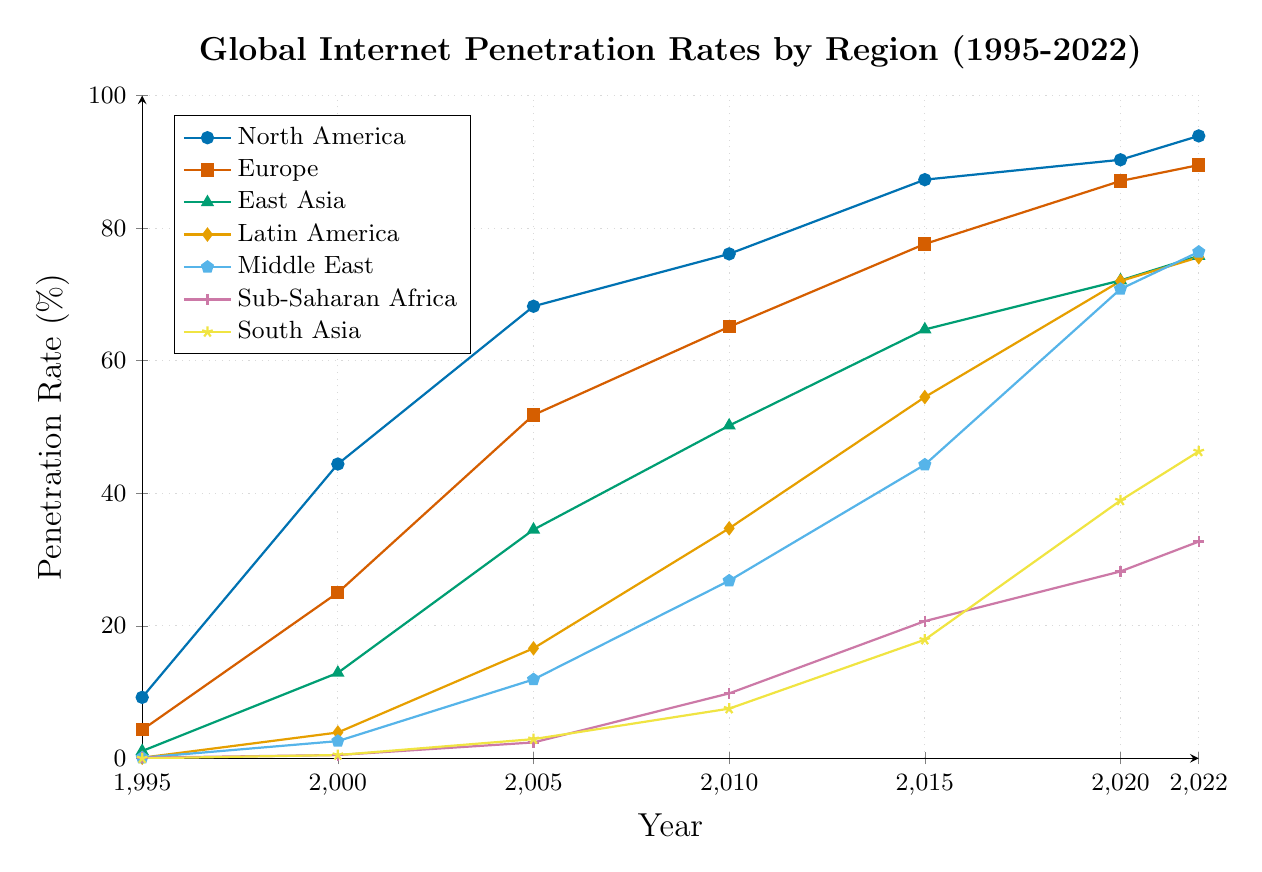What is the internet penetration rate in North America in 2022? To find this, locate the point for North America in 2022, marked with blue circles.
Answer: 93.9% Which region had the lowest internet penetration rate in 1995? Look for the region with the lowest point on the y-axis in 1995. All regions except North America and Europe had a very low rate, but South Asia is at 0.0%.
Answer: South Asia How much did the internet penetration rate increase in Europe from 2000 to 2022? Find the values for Europe in 2000 and 2022 and subtract the 2000 value from the 2022 value. Europe in 2000 was 25.0% and in 2022 it was 89.5%. So, 89.5% - 25.0% = 64.5%.
Answer: 64.5% Compare the internet penetration rates of East Asia and Latin America in 2010. Which region had a higher rate? Locate the points for East Asia and Latin America in 2010. East Asia had an internet penetration rate of 50.2%, while Latin America had 34.7%. 50.2% > 34.7%.
Answer: East Asia In which year did Sub-Saharan Africa surpass a 10% internet penetration rate? Identify the trend line for Sub-Saharan Africa (represented by magenta color) and find the year when it first exceeds 10%. It happens between 2005 (2.4%) and 2010 (9.8%), so the year is 2010.
Answer: 2010 What is the average internet penetration rate in South Asia across all the seven years shown in the chart? Add up the values for South Asia in all the years and divide by the number of years. (0.0 + 0.5 + 2.9 + 7.5 + 17.9 + 38.9 + 46.3) / 7 = 114.0 / 7 = 16.3.
Answer: 16.3 In which year did Middle East have an internet penetration rate close to 70%? Look for the year where the Middle East's penetration rate (represented in cyan) is around 70%. The closest value is in 2020 (70.8%).
Answer: 2020 What was the difference in internet penetration rates between North America and Sub-Saharan Africa in 2005? Find the values for North America and Sub-Saharan Africa in 2005, then subtract the value of Sub-Saharan Africa from North America. 68.2% - 2.4% = 65.8%.
Answer: 65.8% Describe the growth trend of internet penetration in East Asia from 1995 to 2022. The internet penetration rate in East Asia started at 1.1% in 1995 and steadily increased almost every year, reaching 75.8% in 2022, showing continuous and rapid growth.
Answer: Continuous rapid growth Which two regions had the largest gap in internet penetration rates in 2022? Compare the values for all regions in 2022 and find the two with the largest difference. North America had 93.9%, and Sub-Saharan Africa had 32.7%, creating the largest gap.
Answer: North America and Sub-Saharan Africa 